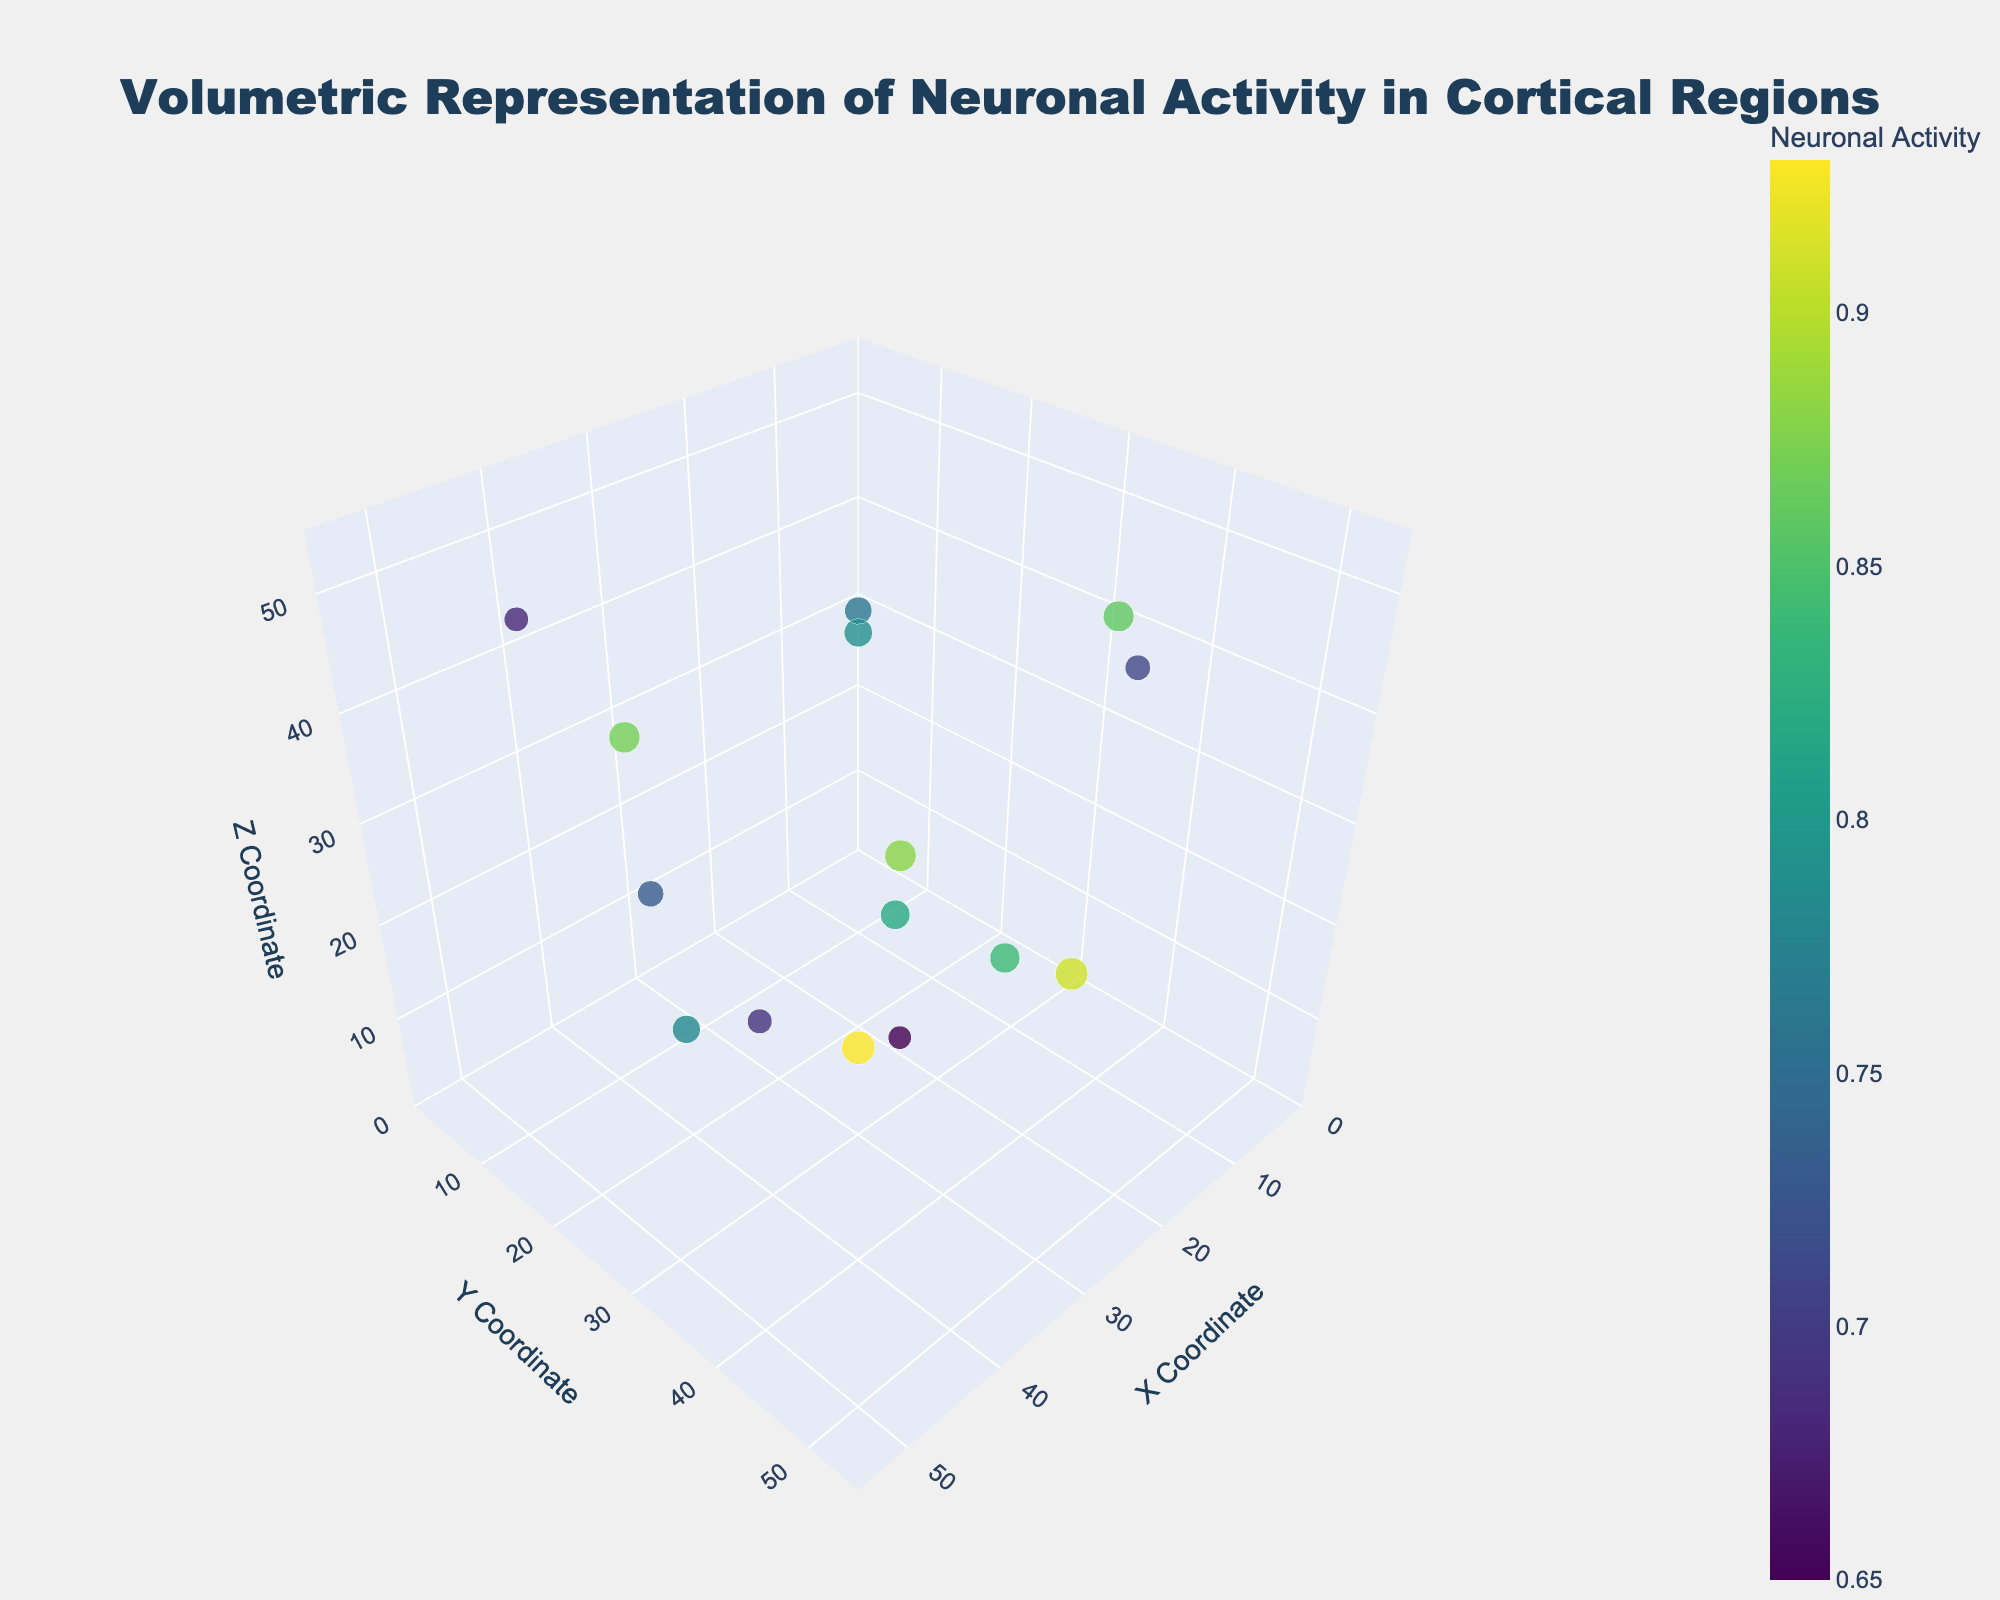What is the title of the figure? The title of the figure can be found at the top and generally provides a concise description of what the figure represents.
Answer: Volumetric Representation of Neuronal Activity in Cortical Regions Which region has the highest neuronal activity, and what is it? We can identify the region with the highest neuronal activity by looking at the size of the markers and their corresponding numeric value in the hover text.
Answer: Orbitofrontal Cortex, 0.93 Which task corresponds to the region situated at coordinates (15, 40, 15)? By finding the specific coordinates in the plot and checking the hover text, we can determine the associated task for the region.
Answer: Episodic Memory Encoding How does the neuronal activity in "Face Recognition" compare to "Visual Processing"? We need to look at the markers and hover information for both tasks and compare their activity values. Face Recognition has an activity of 0.84, while Visual Processing has 0.76.
Answer: Face Recognition has higher activity than Visual Processing What region is represented by the marker with the z-coordinate of 42? We pinpoint the marker with the given z-coordinate and check the hover text to identify the region.
Answer: Insular Cortex What are the coordinates of the region associated with "Language Processing," and what is the activity level? By looking at the hover text information for the task "Language Processing," we can find the corresponding coordinates and activity level.
Answer: (20, 25, 22), 0.88 How many regions show an activity level of 0.8 or higher? By examining the hover text of each marker, we count the number of regions with an activity level meeting or exceeding 0.8.
Answer: 9 regions Which region has more activity: Prefrontal Cortex or Amygdala? By checking the activity values in the hover text for both regions, we find that Prefrontal Cortex has an activity of 0.82, and Amygdala has an activity of 0.87.
Answer: Amygdala has more activity Which regions are involved in language-related tasks, and what are their respective activity levels? The markers associated with Broca's Area and Wernicke's Area correspond to language-related tasks. We extract their activity levels from the hover text.
Answer: Broca's Area: 0.88, Wernicke's Area: 0.69 How does the activity level in "Working Memory" compare with "Motor Planning"? The activity levels for both tasks are found in the hover text, and we compare these values directly. Working Memory has an activity of 0.82, while Motor Planning has 0.79.
Answer: Working Memory has a higher activity level than Motor Planning 